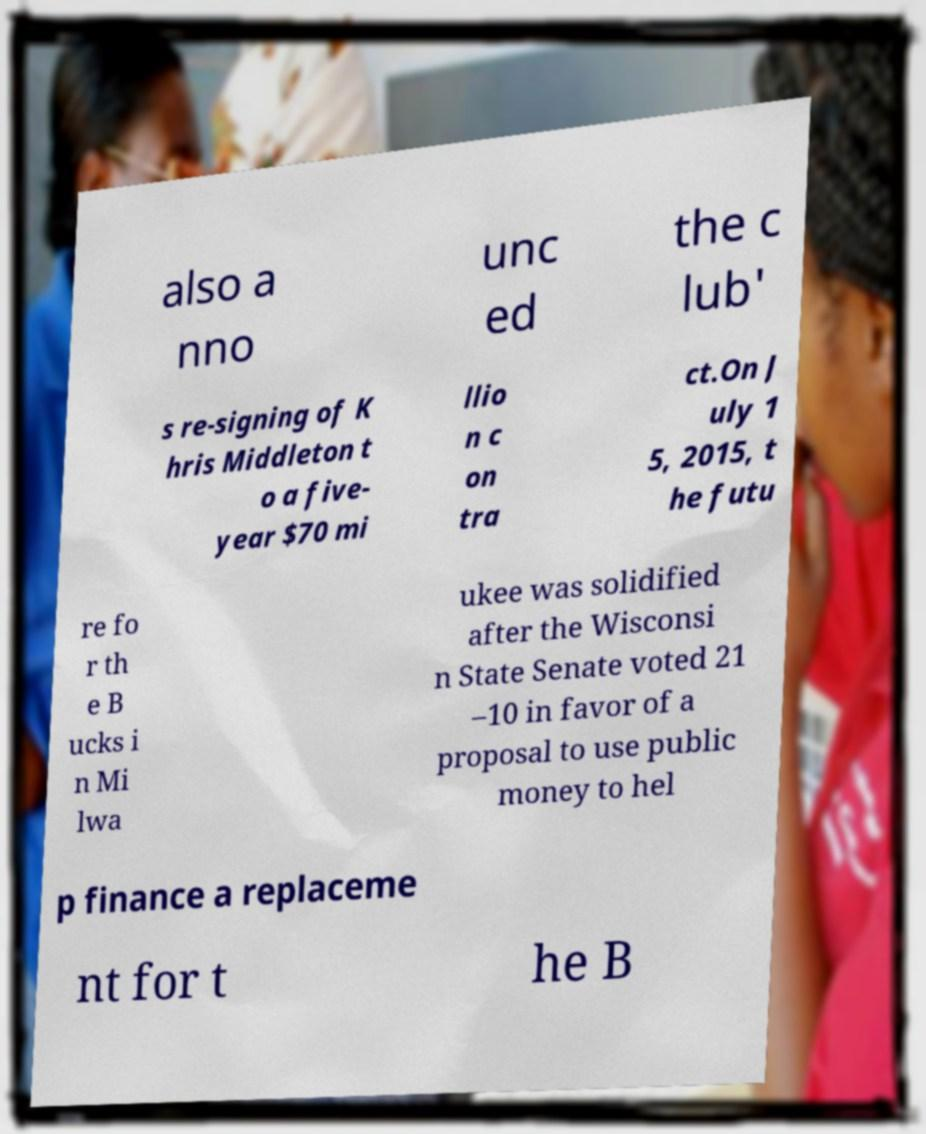Can you accurately transcribe the text from the provided image for me? also a nno unc ed the c lub' s re-signing of K hris Middleton t o a five- year $70 mi llio n c on tra ct.On J uly 1 5, 2015, t he futu re fo r th e B ucks i n Mi lwa ukee was solidified after the Wisconsi n State Senate voted 21 –10 in favor of a proposal to use public money to hel p finance a replaceme nt for t he B 